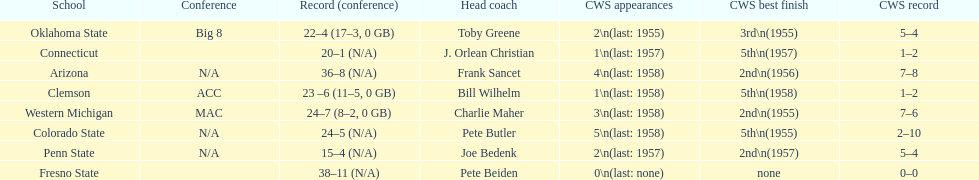Help me parse the entirety of this table. {'header': ['School', 'Conference', 'Record (conference)', 'Head coach', 'CWS appearances', 'CWS best finish', 'CWS record'], 'rows': [['Oklahoma State', 'Big 8', '22–4 (17–3, 0 GB)', 'Toby Greene', '2\\n(last: 1955)', '3rd\\n(1955)', '5–4'], ['Connecticut', '', '20–1 (N/A)', 'J. Orlean Christian', '1\\n(last: 1957)', '5th\\n(1957)', '1–2'], ['Arizona', 'N/A', '36–8 (N/A)', 'Frank Sancet', '4\\n(last: 1958)', '2nd\\n(1956)', '7–8'], ['Clemson', 'ACC', '23 –6 (11–5, 0 GB)', 'Bill Wilhelm', '1\\n(last: 1958)', '5th\\n(1958)', '1–2'], ['Western Michigan', 'MAC', '24–7 (8–2, 0 GB)', 'Charlie Maher', '3\\n(last: 1958)', '2nd\\n(1955)', '7–6'], ['Colorado State', 'N/A', '24–5 (N/A)', 'Pete Butler', '5\\n(last: 1958)', '5th\\n(1955)', '2–10'], ['Penn State', 'N/A', '15–4 (N/A)', 'Joe Bedenk', '2\\n(last: 1957)', '2nd\\n(1957)', '5–4'], ['Fresno State', '', '38–11 (N/A)', 'Pete Beiden', '0\\n(last: none)', 'none', '0–0']]} List the schools that came in last place in the cws best finish. Clemson, Colorado State, Connecticut. 